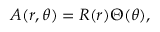<formula> <loc_0><loc_0><loc_500><loc_500>A ( r , \theta ) = R ( r ) \Theta ( \theta ) ,</formula> 